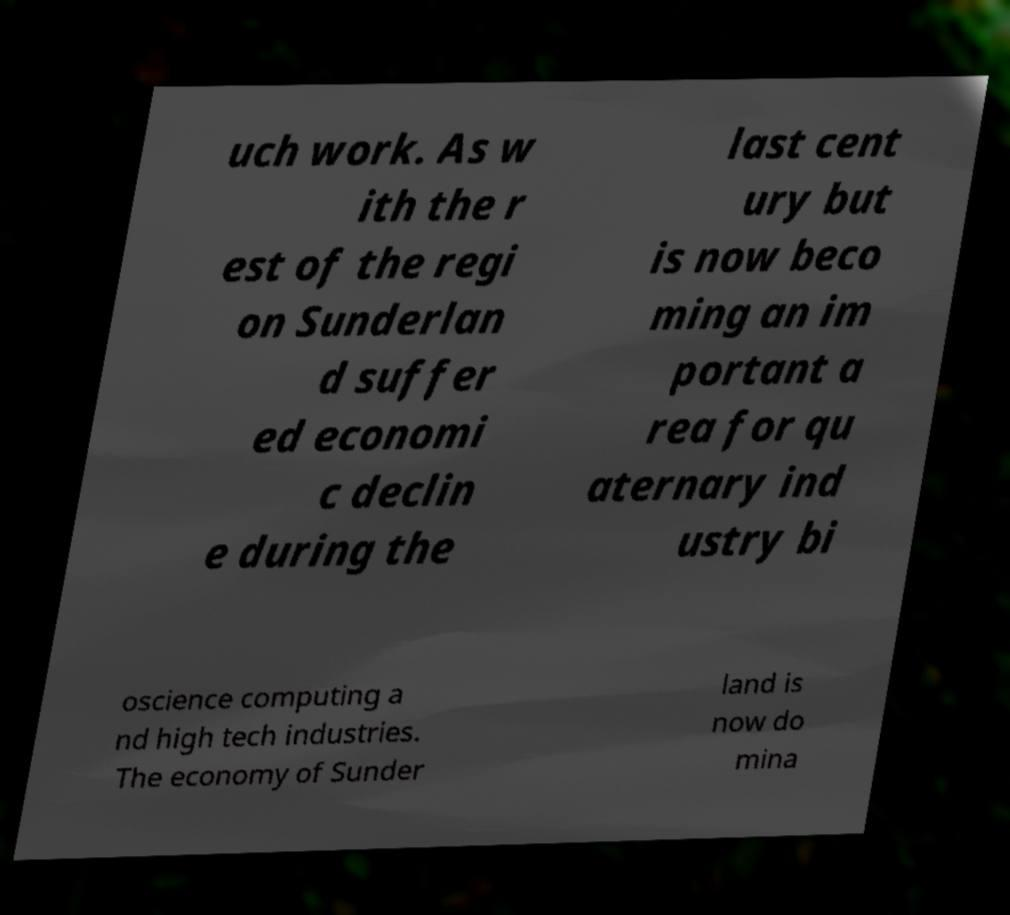What messages or text are displayed in this image? I need them in a readable, typed format. uch work. As w ith the r est of the regi on Sunderlan d suffer ed economi c declin e during the last cent ury but is now beco ming an im portant a rea for qu aternary ind ustry bi oscience computing a nd high tech industries. The economy of Sunder land is now do mina 